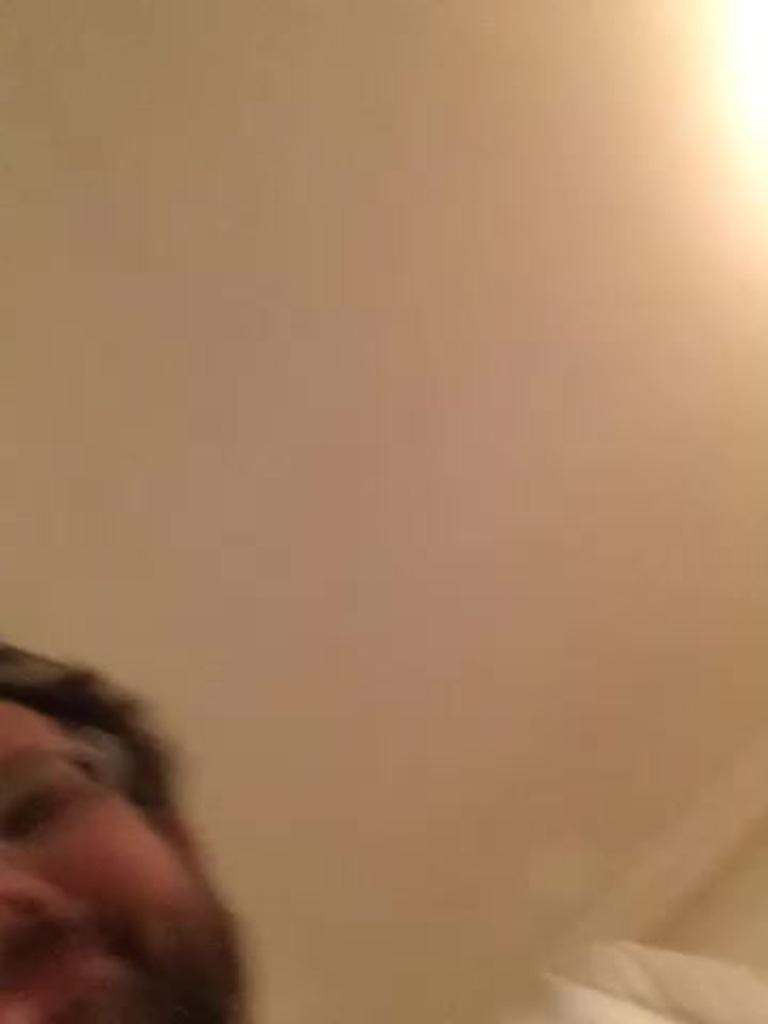In one or two sentences, can you explain what this image depicts? It is a blur image,the half face of the man is visible in the picture. 